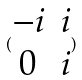<formula> <loc_0><loc_0><loc_500><loc_500>( \begin{matrix} - i & i \\ 0 & i \end{matrix} )</formula> 